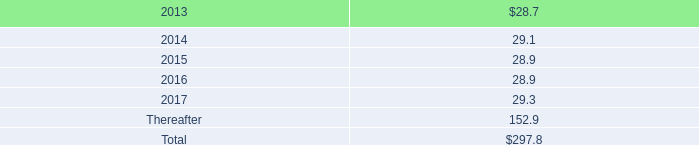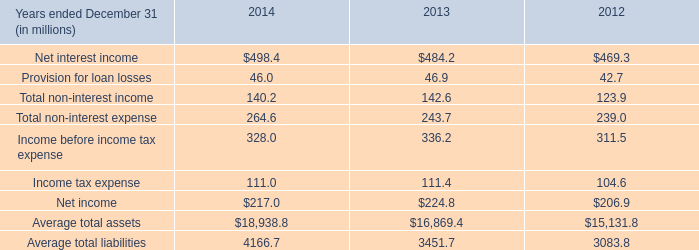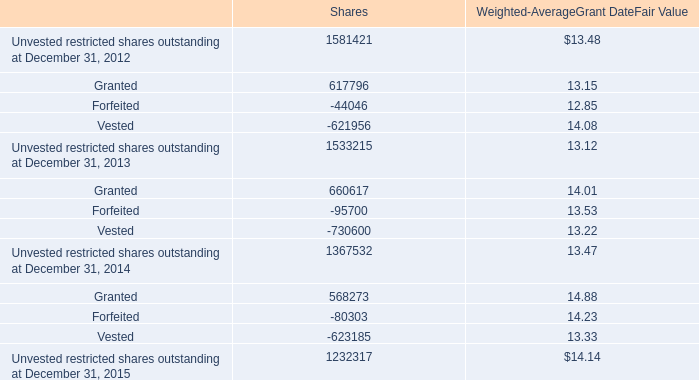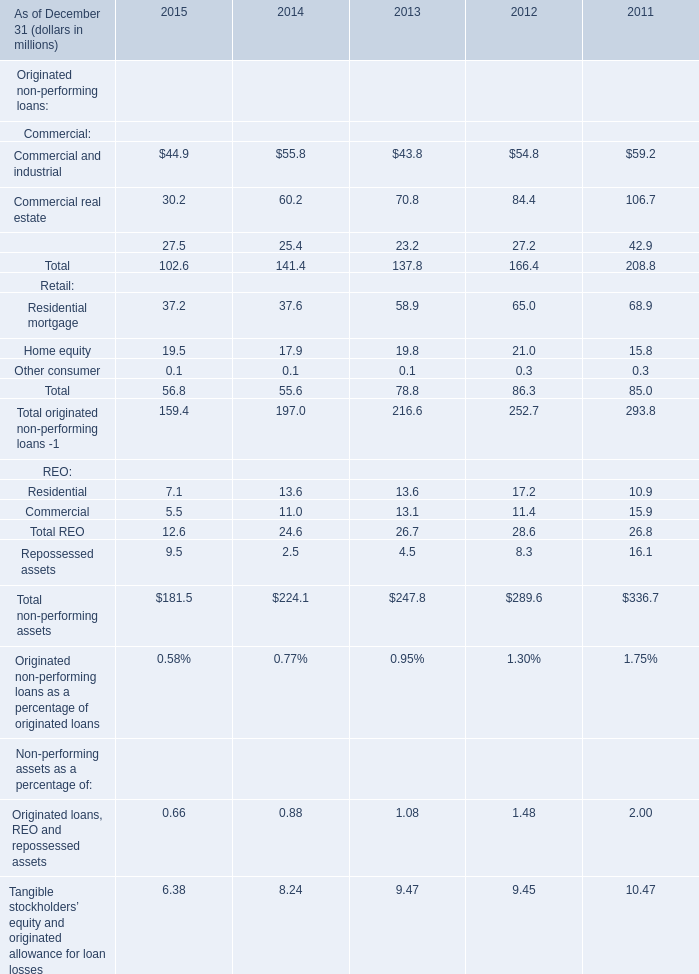What will Home equity be like in 2015 if it develops with the same increasing rate as current? (in million) 
Computations: ((((19.5 - 17.9) / 17.9) + 1) * 19.5)
Answer: 21.24302. 